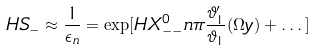Convert formula to latex. <formula><loc_0><loc_0><loc_500><loc_500>H S _ { - } \approx \frac { 1 } { \epsilon _ { n } } = \exp [ H X _ { - - } ^ { 0 } n \pi \frac { \vartheta _ { 1 } ^ { \prime } } { \vartheta _ { 1 } } ( \Omega y ) + \dots ]</formula> 